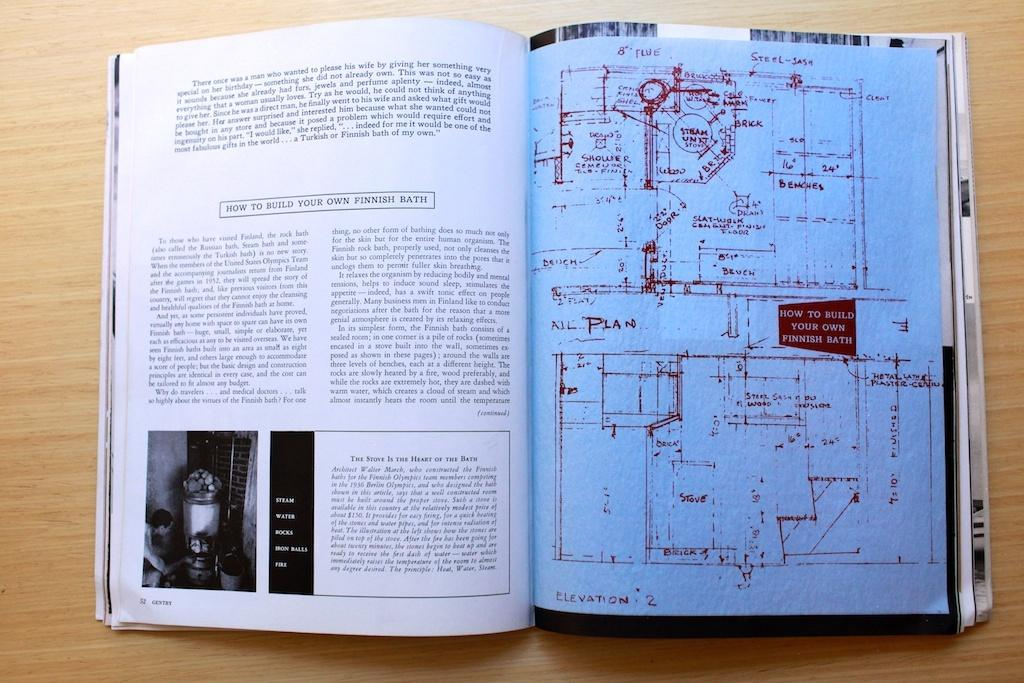<image>
Relay a brief, clear account of the picture shown. a book on How to Build your own Finnish Bath 